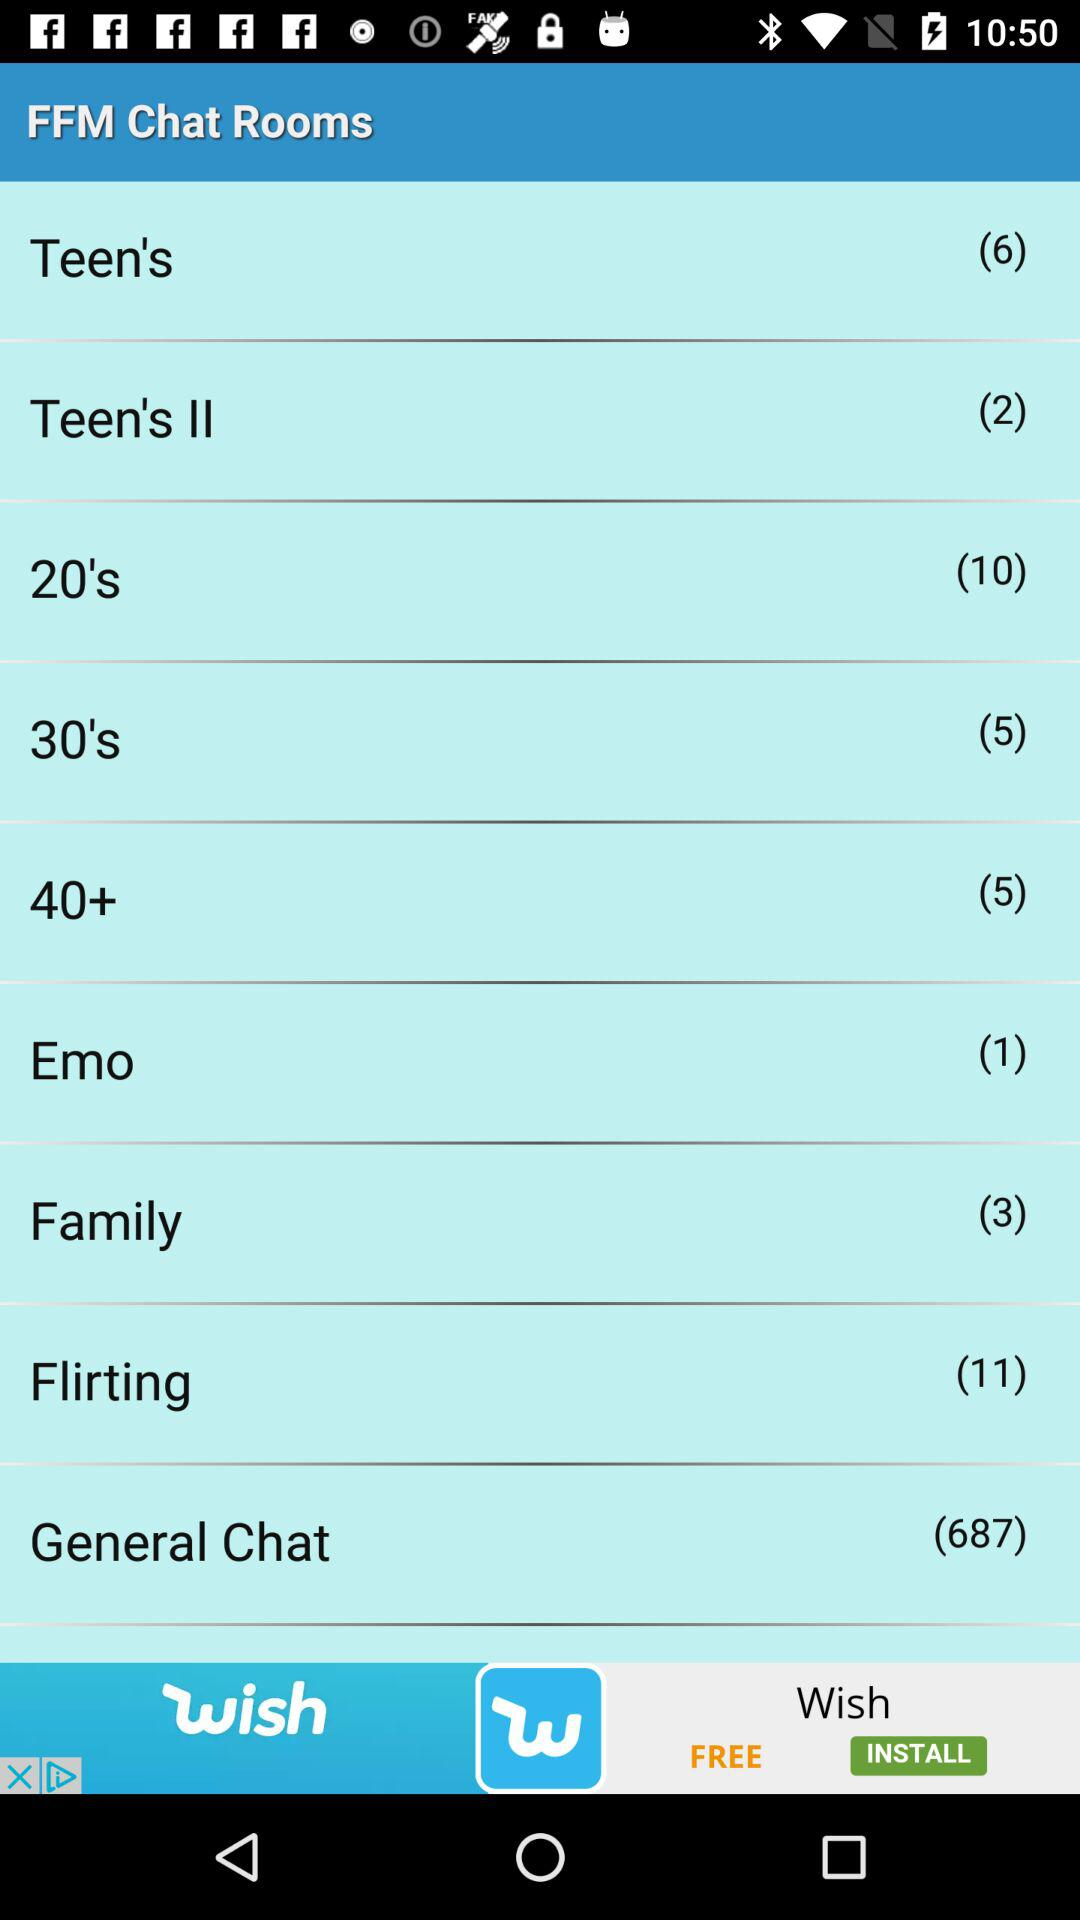What themes are available for age-specific chat rooms in this list? The age-specific chat rooms available in this list are 'Teen's', 'Teen's II', '20's', and '40+'. Each room likely caters to the interests and discussions pertinent to these age groups. 